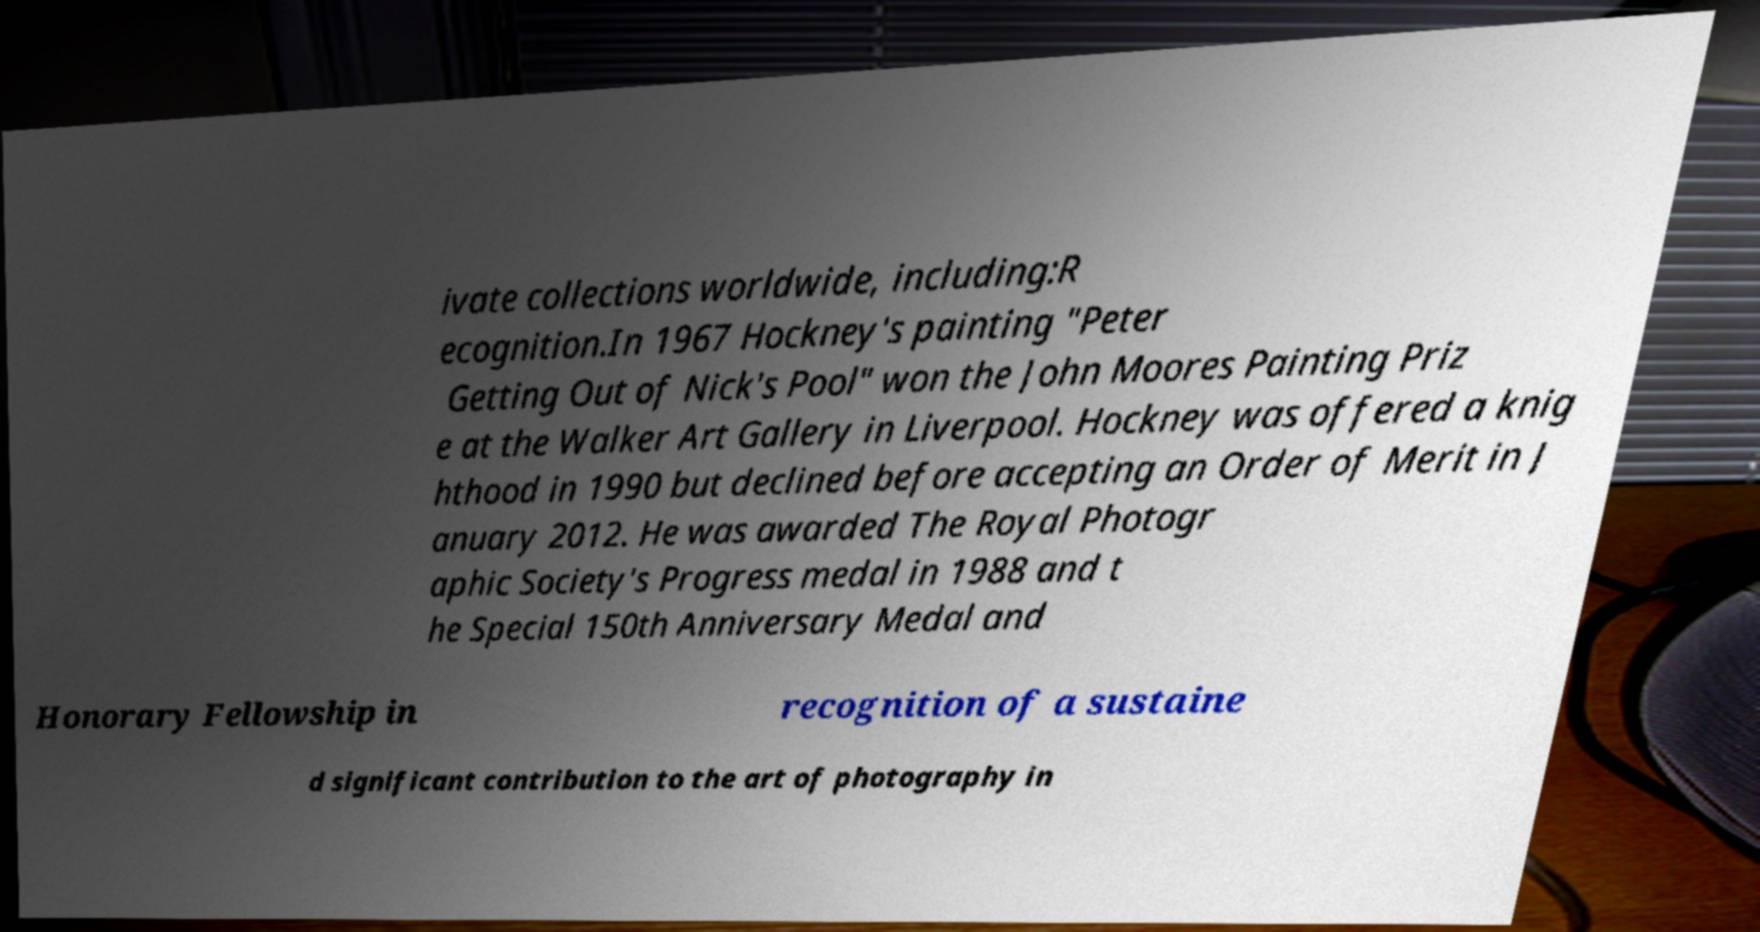For documentation purposes, I need the text within this image transcribed. Could you provide that? ivate collections worldwide, including:R ecognition.In 1967 Hockney's painting "Peter Getting Out of Nick's Pool" won the John Moores Painting Priz e at the Walker Art Gallery in Liverpool. Hockney was offered a knig hthood in 1990 but declined before accepting an Order of Merit in J anuary 2012. He was awarded The Royal Photogr aphic Society's Progress medal in 1988 and t he Special 150th Anniversary Medal and Honorary Fellowship in recognition of a sustaine d significant contribution to the art of photography in 